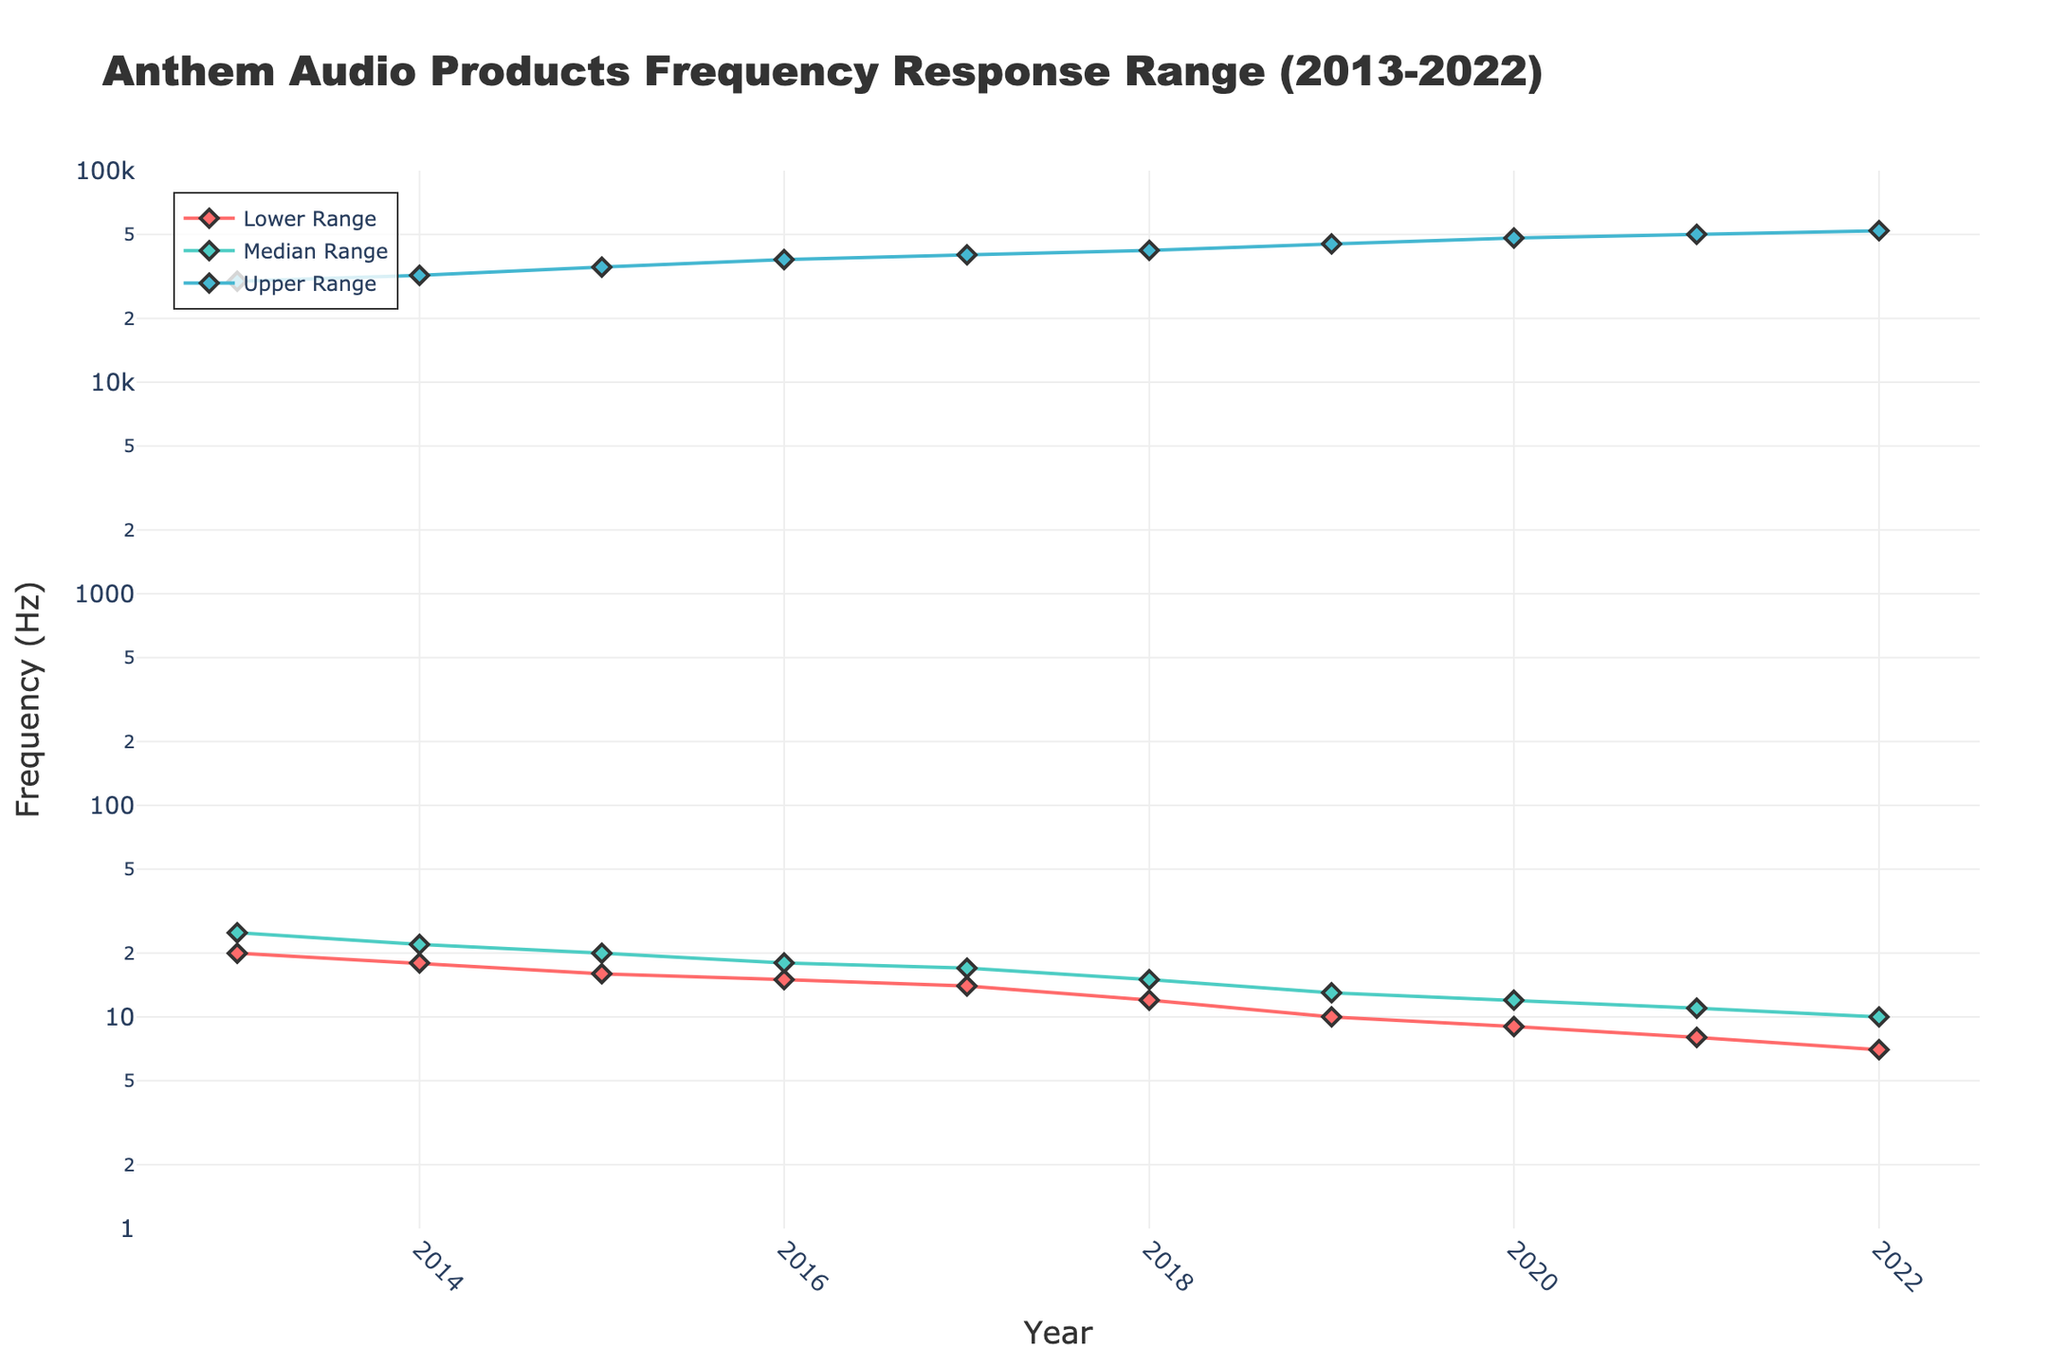What product was released in 2020? Look for the year 2020 on the x-axis and check the associated annotation for the model name.
Answer: Anthem STR Power Amplifier What is the frequency range for the Anthem MRX 1120? Find the data point for Anthem MRX 1120, then read off the lower, median, and upper ranges from the y-axis and hover text.
Answer: 15 Hz to 38,000 Hz How does the frequency range of the Anthem AVM 90 compare to the Anthem AVM 60? Compare the lower, median, and upper ranges for both models shown in their respective hover texts.
Answer: AVM 90 has lower and higher frequency ranges (7-52,000 Hz vs. 12-42,000 Hz) What trend can be observed in the upper frequency range over the years? Observe the line plot for the Upper Range over the years to identify if it increases, decreases, or remains stable.
Answer: The upper range steadily increases over the years Which year had the product with the lowest median frequency range? Identify the year where the median frequency range is the lowest by comparing the median range data points.
Answer: 2022 Compare the lower frequency ranges between 2016 and 2021. Identify the lower frequency values for these years and compare them.
Answer: The range decreased from 15 Hz in 2016 to 8 Hz in 2021 What is the change in the upper frequency range from 2013 to 2022? Subtract the upper frequency range of 2013 (30,000 Hz) from that of 2022 (52,000 Hz).
Answer: 22,000 Hz Which model has the highest median frequency response in the dataset? Check the hover text for the Median Range and identify the model with the highest median value.
Answer: Anthem AVM 90 How does the trend of the median frequency range compare to the upper frequency range? Observe both curves' trends in the plot and compare their directions and slopes.
Answer: Both the median and upper frequency ranges increase over the years 